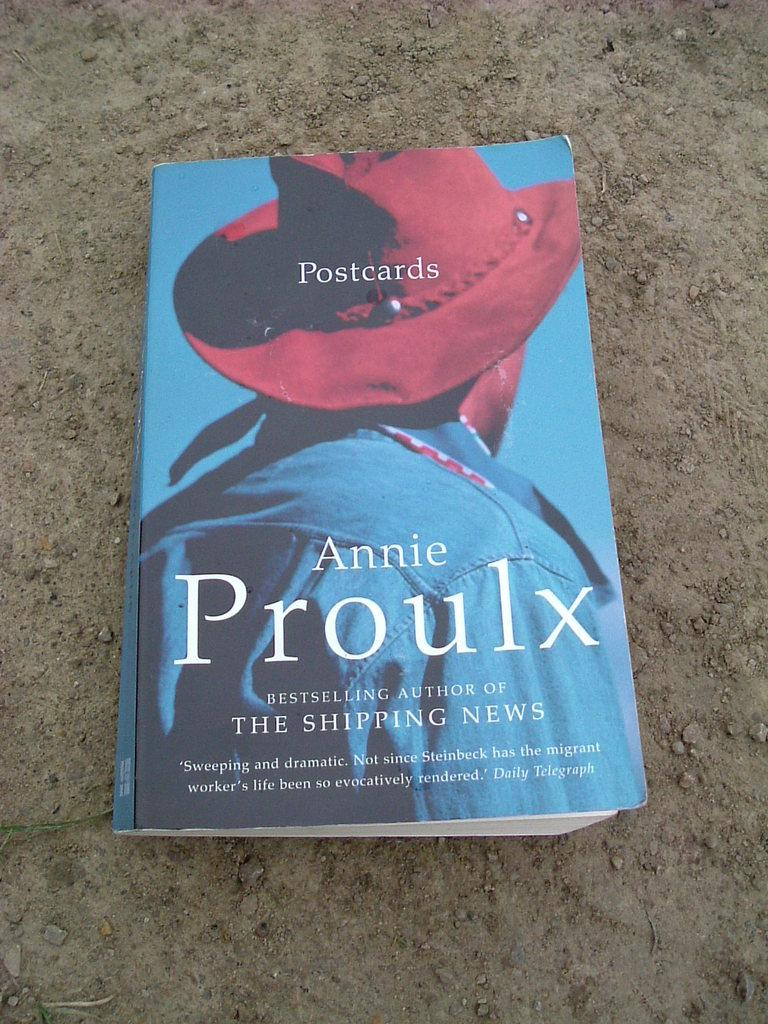<image>
Write a terse but informative summary of the picture. Postcards by Annie Proulx sits on a counter top. 